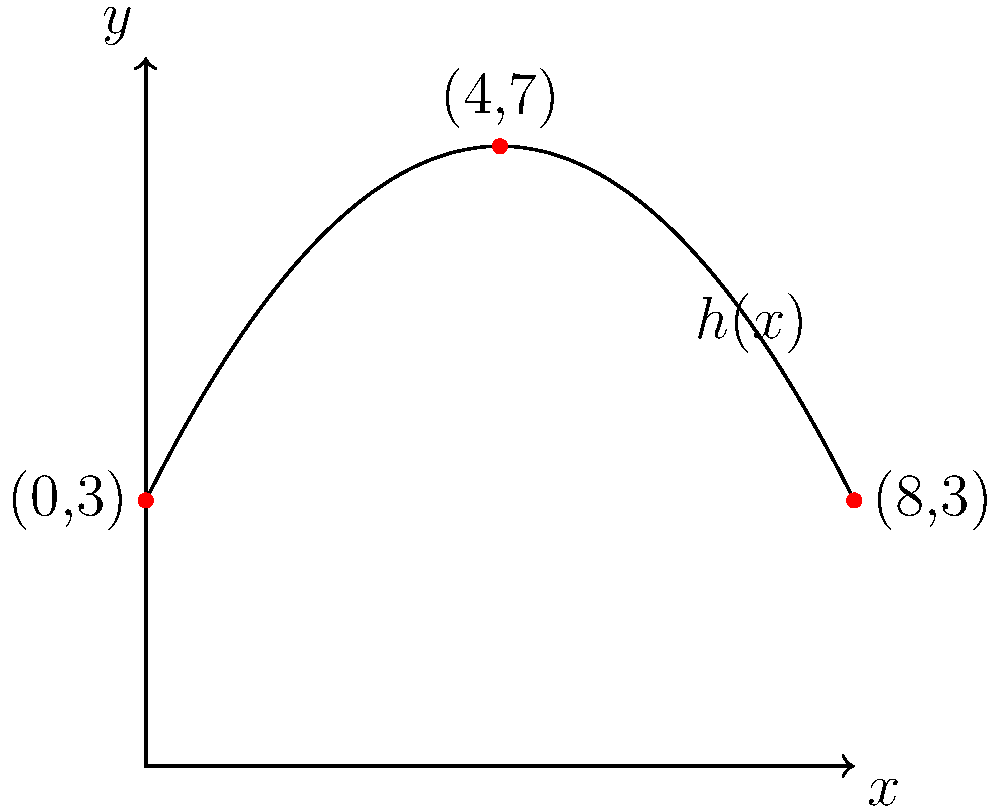A security camera's field of view can be modeled by the parabolic function $h(x) = -0.25x^2 + 2x + 3$, where $h(x)$ represents the height in meters and $x$ represents the horizontal distance in meters. What is the maximum height of the camera's field of view? To find the maximum height of the security camera's field of view, we need to determine the vertex of the parabola. For a quadratic function in the form $f(x) = ax^2 + bx + c$, the x-coordinate of the vertex is given by $x = -\frac{b}{2a}$.

Step 1: Identify $a$ and $b$ from the given function $h(x) = -0.25x^2 + 2x + 3$
$a = -0.25$
$b = 2$

Step 2: Calculate the x-coordinate of the vertex
$x = -\frac{b}{2a} = -\frac{2}{2(-0.25)} = 4$

Step 3: Find the maximum height by plugging the x-coordinate into the original function
$h(4) = -0.25(4)^2 + 2(4) + 3$
$= -0.25(16) + 8 + 3$
$= -4 + 8 + 3$
$= 7$

Therefore, the maximum height of the camera's field of view is 7 meters.
Answer: 7 meters 